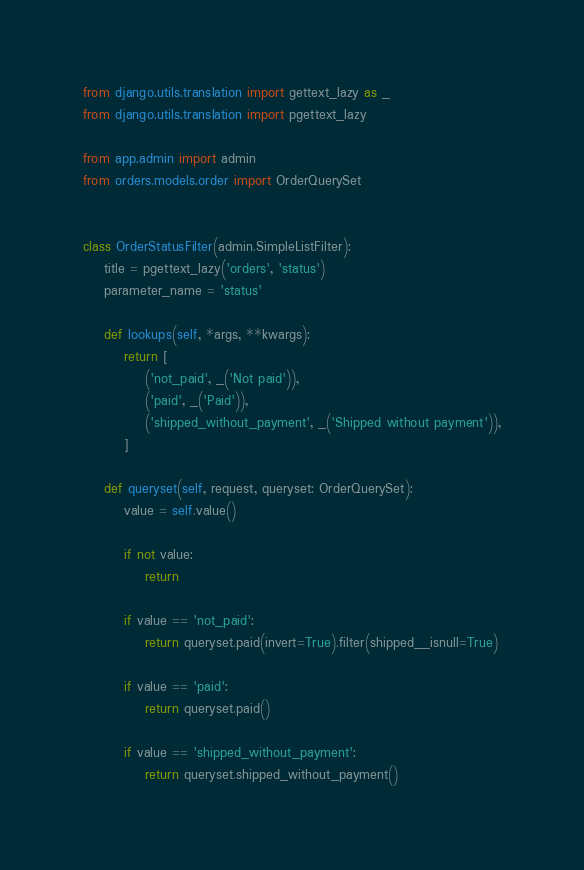<code> <loc_0><loc_0><loc_500><loc_500><_Python_>from django.utils.translation import gettext_lazy as _
from django.utils.translation import pgettext_lazy

from app.admin import admin
from orders.models.order import OrderQuerySet


class OrderStatusFilter(admin.SimpleListFilter):
    title = pgettext_lazy('orders', 'status')
    parameter_name = 'status'

    def lookups(self, *args, **kwargs):
        return [
            ('not_paid', _('Not paid')),
            ('paid', _('Paid')),
            ('shipped_without_payment', _('Shipped without payment')),
        ]

    def queryset(self, request, queryset: OrderQuerySet):
        value = self.value()

        if not value:
            return

        if value == 'not_paid':
            return queryset.paid(invert=True).filter(shipped__isnull=True)

        if value == 'paid':
            return queryset.paid()

        if value == 'shipped_without_payment':
            return queryset.shipped_without_payment()
</code> 